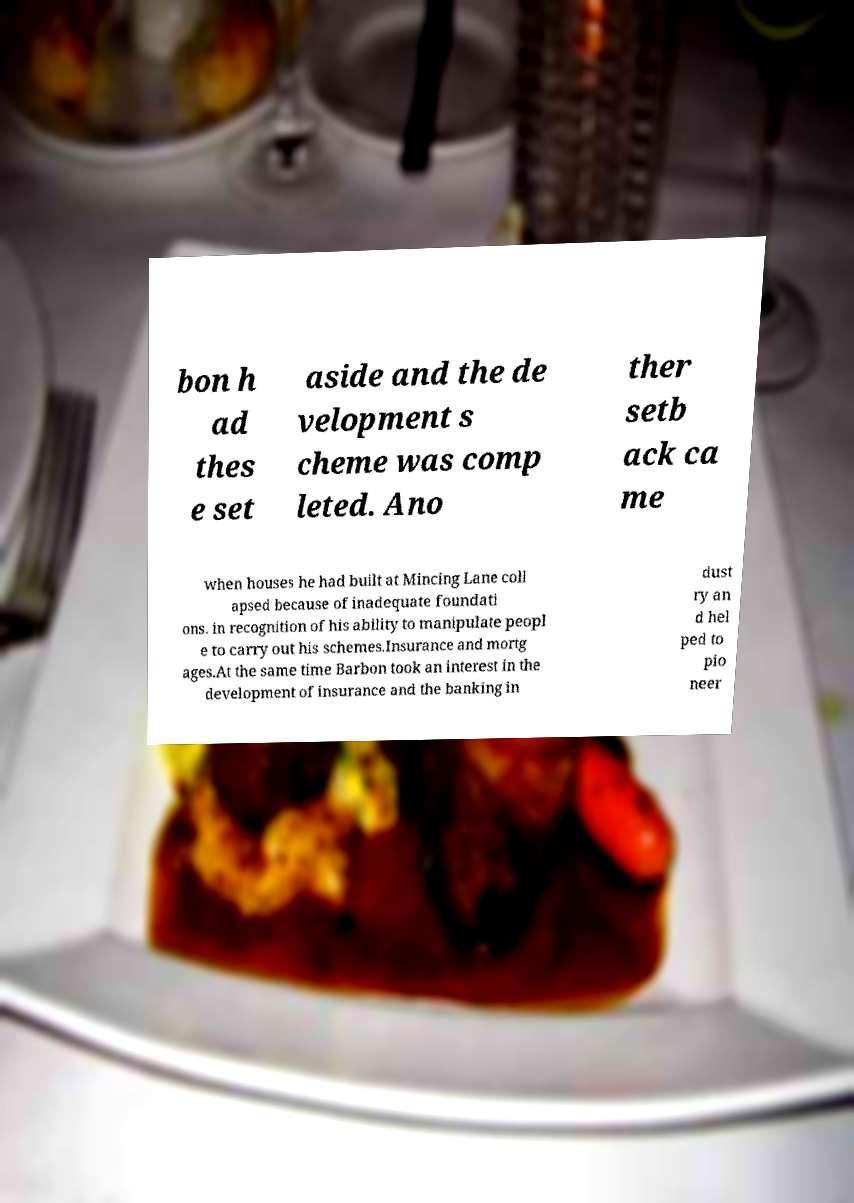Could you assist in decoding the text presented in this image and type it out clearly? bon h ad thes e set aside and the de velopment s cheme was comp leted. Ano ther setb ack ca me when houses he had built at Mincing Lane coll apsed because of inadequate foundati ons. in recognition of his ability to manipulate peopl e to carry out his schemes.Insurance and mortg ages.At the same time Barbon took an interest in the development of insurance and the banking in dust ry an d hel ped to pio neer 